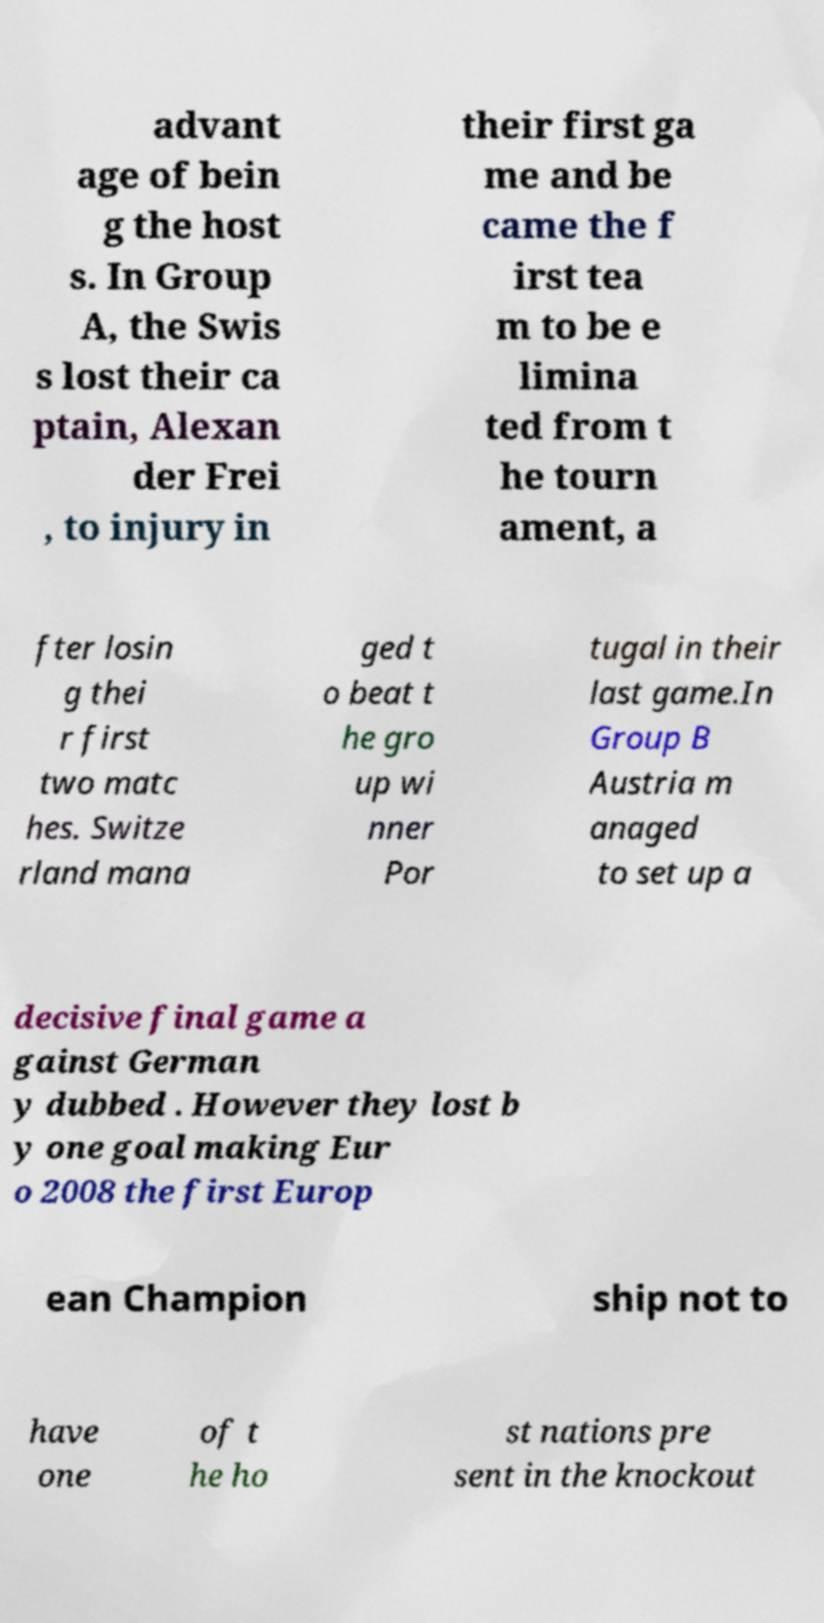Could you extract and type out the text from this image? advant age of bein g the host s. In Group A, the Swis s lost their ca ptain, Alexan der Frei , to injury in their first ga me and be came the f irst tea m to be e limina ted from t he tourn ament, a fter losin g thei r first two matc hes. Switze rland mana ged t o beat t he gro up wi nner Por tugal in their last game.In Group B Austria m anaged to set up a decisive final game a gainst German y dubbed . However they lost b y one goal making Eur o 2008 the first Europ ean Champion ship not to have one of t he ho st nations pre sent in the knockout 